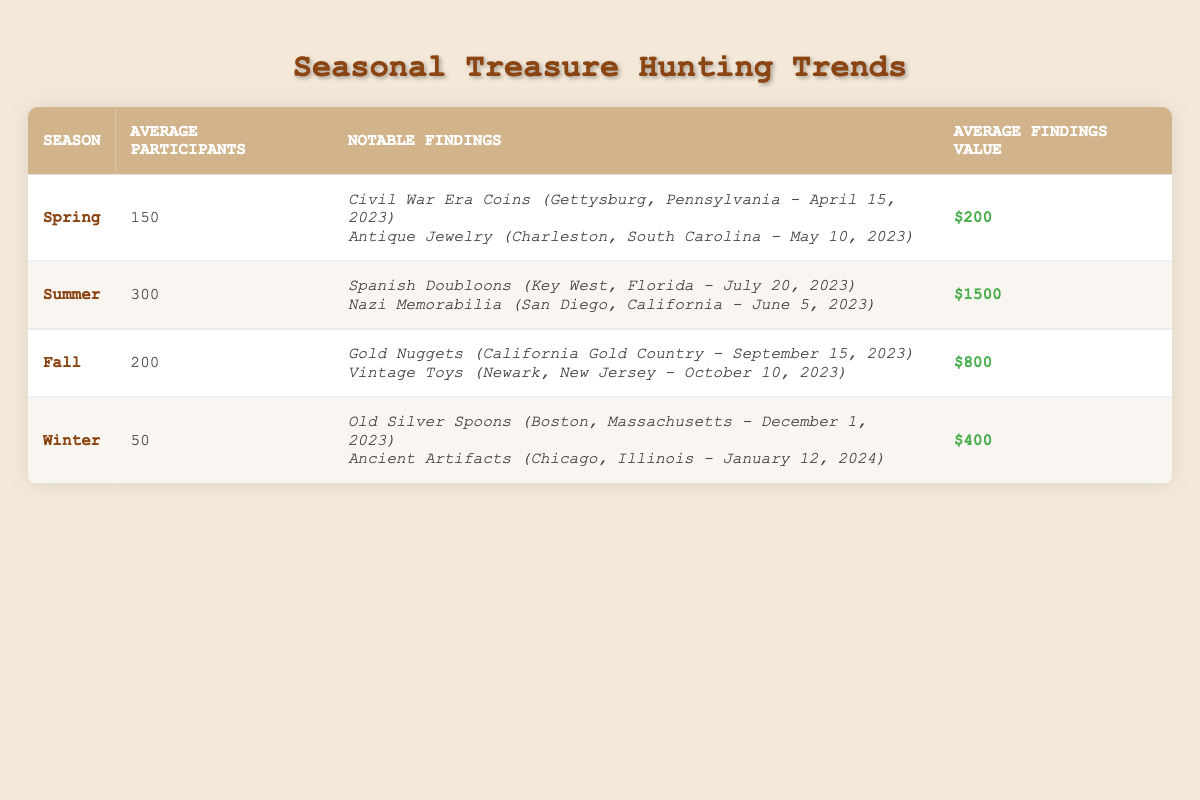What is the average number of participants during the summer season? The summer season has an average of 300 participants listed in the table specifically under that column.
Answer: 300 Which season has the highest average findings value? By comparing the average findings value for each season, the summer season has the highest value at $1500, which is noted in that column.
Answer: Summer Are there more notable findings recorded in the fall than in winter? The fall season records two notable findings, while the winter season also has two notable findings, thus they are equal.
Answer: No What is the total number of average participants across all seasons? We sum the average participants: 150 (Spring) + 300 (Summer) + 200 (Fall) + 50 (Winter) = 700.
Answer: 700 In which season was antique jewelry found? The notable findings indicate that antique jewelry was found during the spring season on May 10, 2023, as it is listed under spring.
Answer: Spring What is the value difference between the average findings in summer and winter? The average findings in summer are $1500 and in winter are $400. The difference is $1500 - $400 = $1100.
Answer: $1100 Is it true that gold nuggets were found in the spring season? Gold nuggets are listed as a notable finding in the fall season, therefore this statement is false.
Answer: No Which season features the lowest number of average participants? The table shows winter having the lowest average participants with only 50, while all other seasons have higher averages.
Answer: Winter What is the ratio of average findings value in summer to that in winter? Average findings in summer are $1500 and in winter are $400. The ratio is $1500:$400, which simplifies to 15:4.
Answer: 15:4 How many notable findings were recorded in total across all seasons? By counting the notable findings listed for each season, there are 2 from spring, 2 from summer, 2 from fall, and 2 from winter, totaling 8.
Answer: 8 